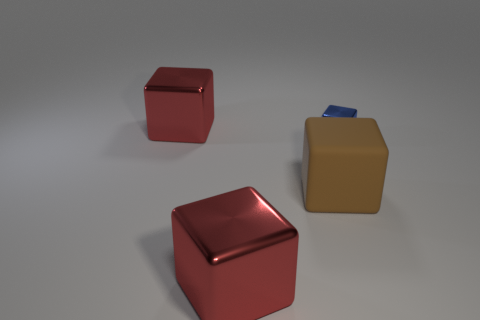Subtract all blue metal cubes. How many cubes are left? 3 Add 1 small metal objects. How many objects exist? 5 Subtract all red cubes. How many cubes are left? 2 Subtract all gray balls. How many red cubes are left? 2 Subtract 0 blue cylinders. How many objects are left? 4 Subtract 2 blocks. How many blocks are left? 2 Subtract all red blocks. Subtract all purple cylinders. How many blocks are left? 2 Subtract all large matte cubes. Subtract all blue objects. How many objects are left? 2 Add 3 tiny blue objects. How many tiny blue objects are left? 4 Add 3 big brown things. How many big brown things exist? 4 